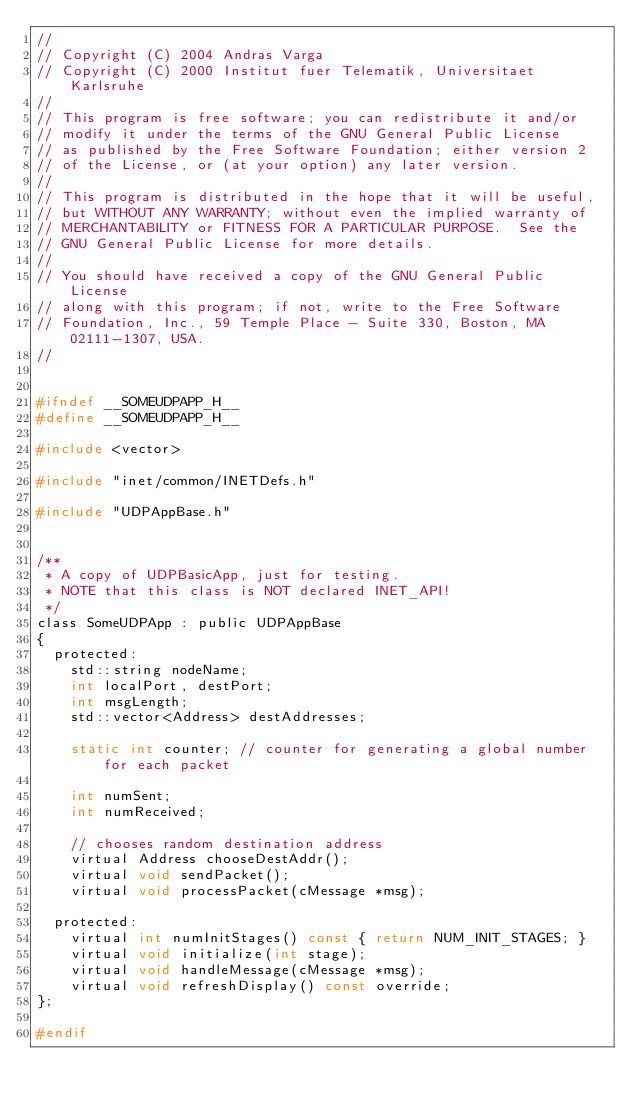<code> <loc_0><loc_0><loc_500><loc_500><_C_>//
// Copyright (C) 2004 Andras Varga
// Copyright (C) 2000 Institut fuer Telematik, Universitaet Karlsruhe
//
// This program is free software; you can redistribute it and/or
// modify it under the terms of the GNU General Public License
// as published by the Free Software Foundation; either version 2
// of the License, or (at your option) any later version.
//
// This program is distributed in the hope that it will be useful,
// but WITHOUT ANY WARRANTY; without even the implied warranty of
// MERCHANTABILITY or FITNESS FOR A PARTICULAR PURPOSE.  See the
// GNU General Public License for more details.
//
// You should have received a copy of the GNU General Public License
// along with this program; if not, write to the Free Software
// Foundation, Inc., 59 Temple Place - Suite 330, Boston, MA  02111-1307, USA.
//


#ifndef __SOMEUDPAPP_H__
#define __SOMEUDPAPP_H__

#include <vector>

#include "inet/common/INETDefs.h"

#include "UDPAppBase.h"


/**
 * A copy of UDPBasicApp, just for testing.
 * NOTE that this class is NOT declared INET_API!
 */
class SomeUDPApp : public UDPAppBase
{
  protected:
    std::string nodeName;
    int localPort, destPort;
    int msgLength;
    std::vector<Address> destAddresses;

    static int counter; // counter for generating a global number for each packet

    int numSent;
    int numReceived;

    // chooses random destination address
    virtual Address chooseDestAddr();
    virtual void sendPacket();
    virtual void processPacket(cMessage *msg);

  protected:
    virtual int numInitStages() const { return NUM_INIT_STAGES; }
    virtual void initialize(int stage);
    virtual void handleMessage(cMessage *msg);
    virtual void refreshDisplay() const override;
};

#endif

</code> 